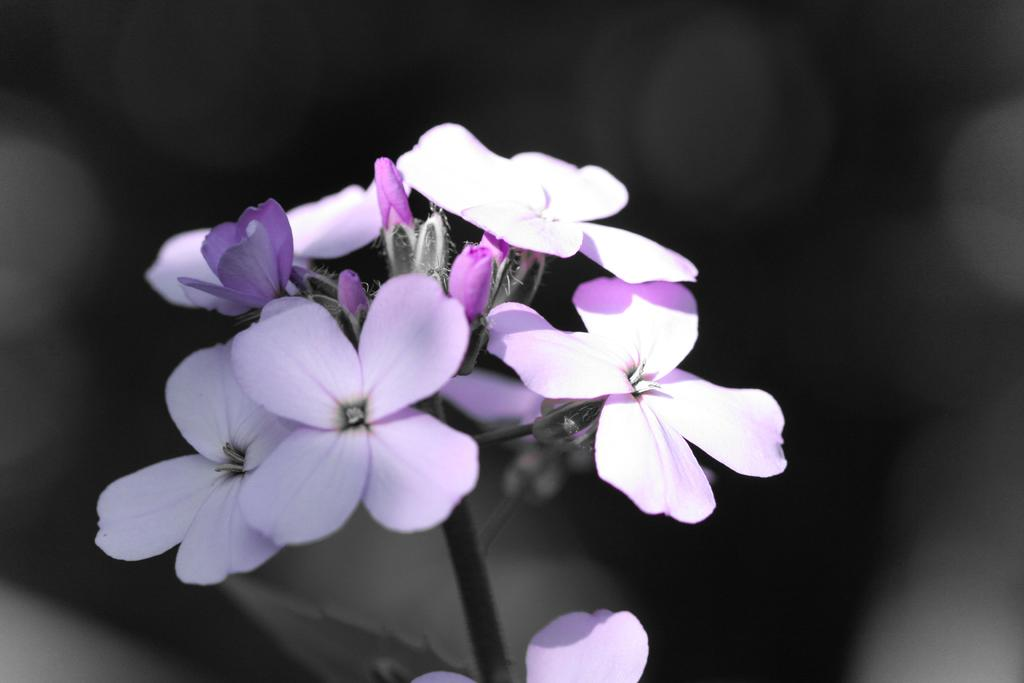What type of plants can be seen in the front of the image? There are flowers in the front of the image. What type of card can be seen in the aftermath of the knee injury in the image? There is no knee injury or card present in the image; it only features flowers in the front. 